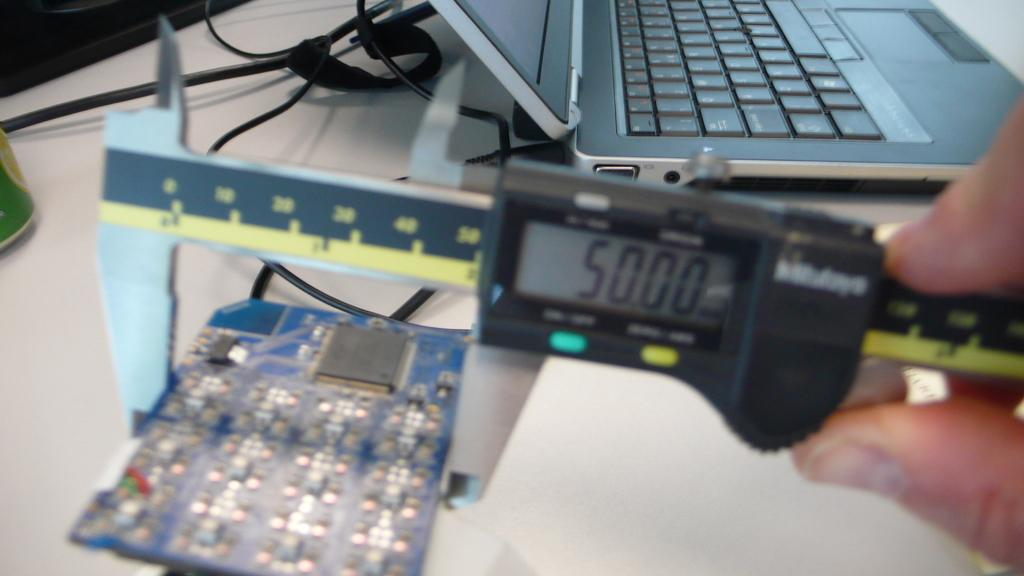<image>
Offer a succinct explanation of the picture presented. A computer chip and a measurement tool reading 50.00 